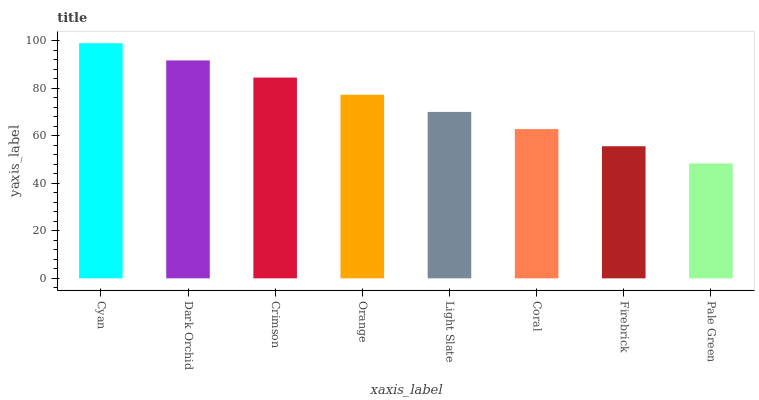Is Pale Green the minimum?
Answer yes or no. Yes. Is Cyan the maximum?
Answer yes or no. Yes. Is Dark Orchid the minimum?
Answer yes or no. No. Is Dark Orchid the maximum?
Answer yes or no. No. Is Cyan greater than Dark Orchid?
Answer yes or no. Yes. Is Dark Orchid less than Cyan?
Answer yes or no. Yes. Is Dark Orchid greater than Cyan?
Answer yes or no. No. Is Cyan less than Dark Orchid?
Answer yes or no. No. Is Orange the high median?
Answer yes or no. Yes. Is Light Slate the low median?
Answer yes or no. Yes. Is Coral the high median?
Answer yes or no. No. Is Dark Orchid the low median?
Answer yes or no. No. 